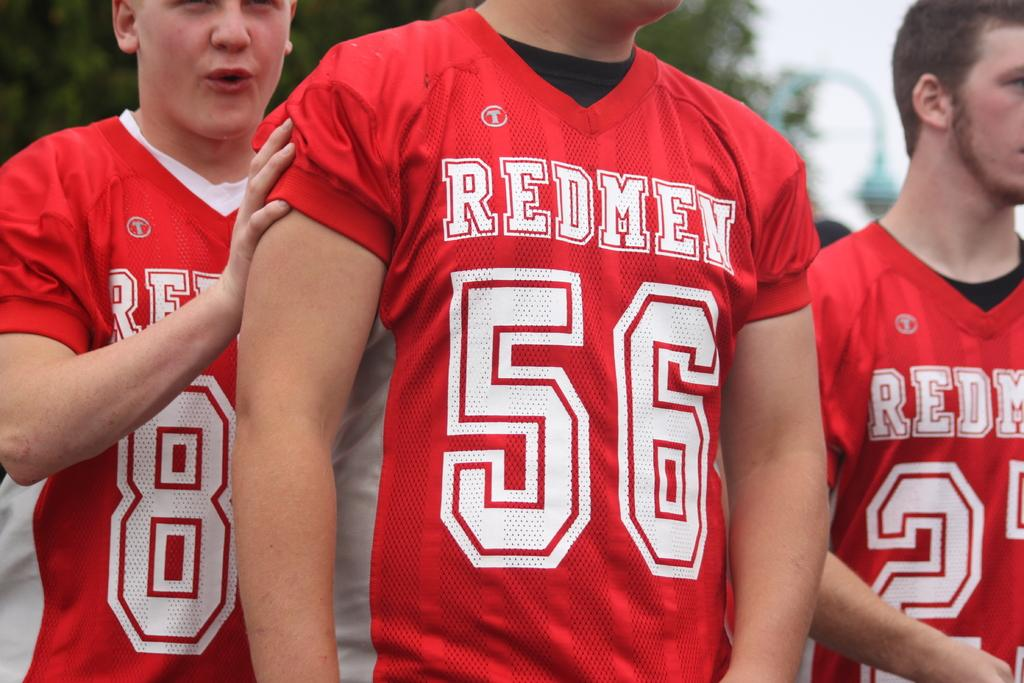<image>
Render a clear and concise summary of the photo. A close up of three young boys wearing Redmen football jerseys. 